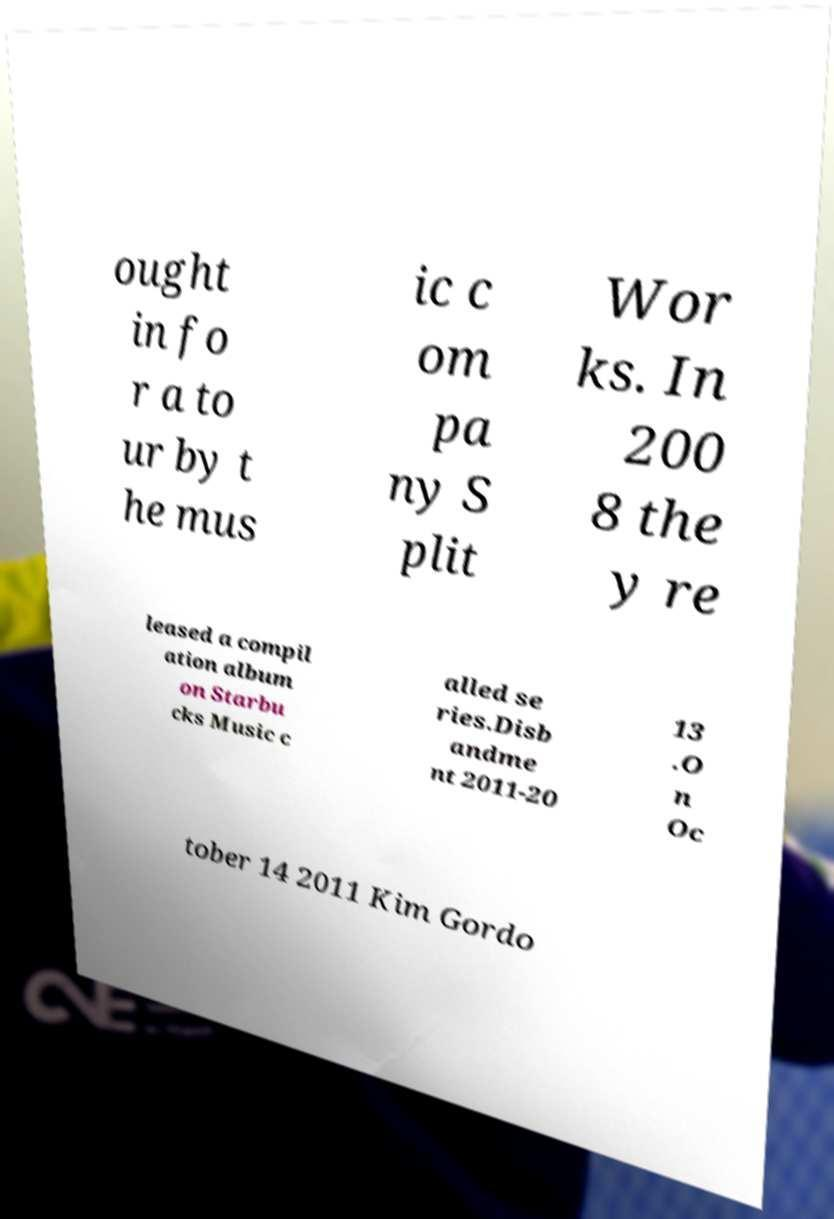Could you extract and type out the text from this image? ought in fo r a to ur by t he mus ic c om pa ny S plit Wor ks. In 200 8 the y re leased a compil ation album on Starbu cks Music c alled se ries.Disb andme nt 2011-20 13 .O n Oc tober 14 2011 Kim Gordo 